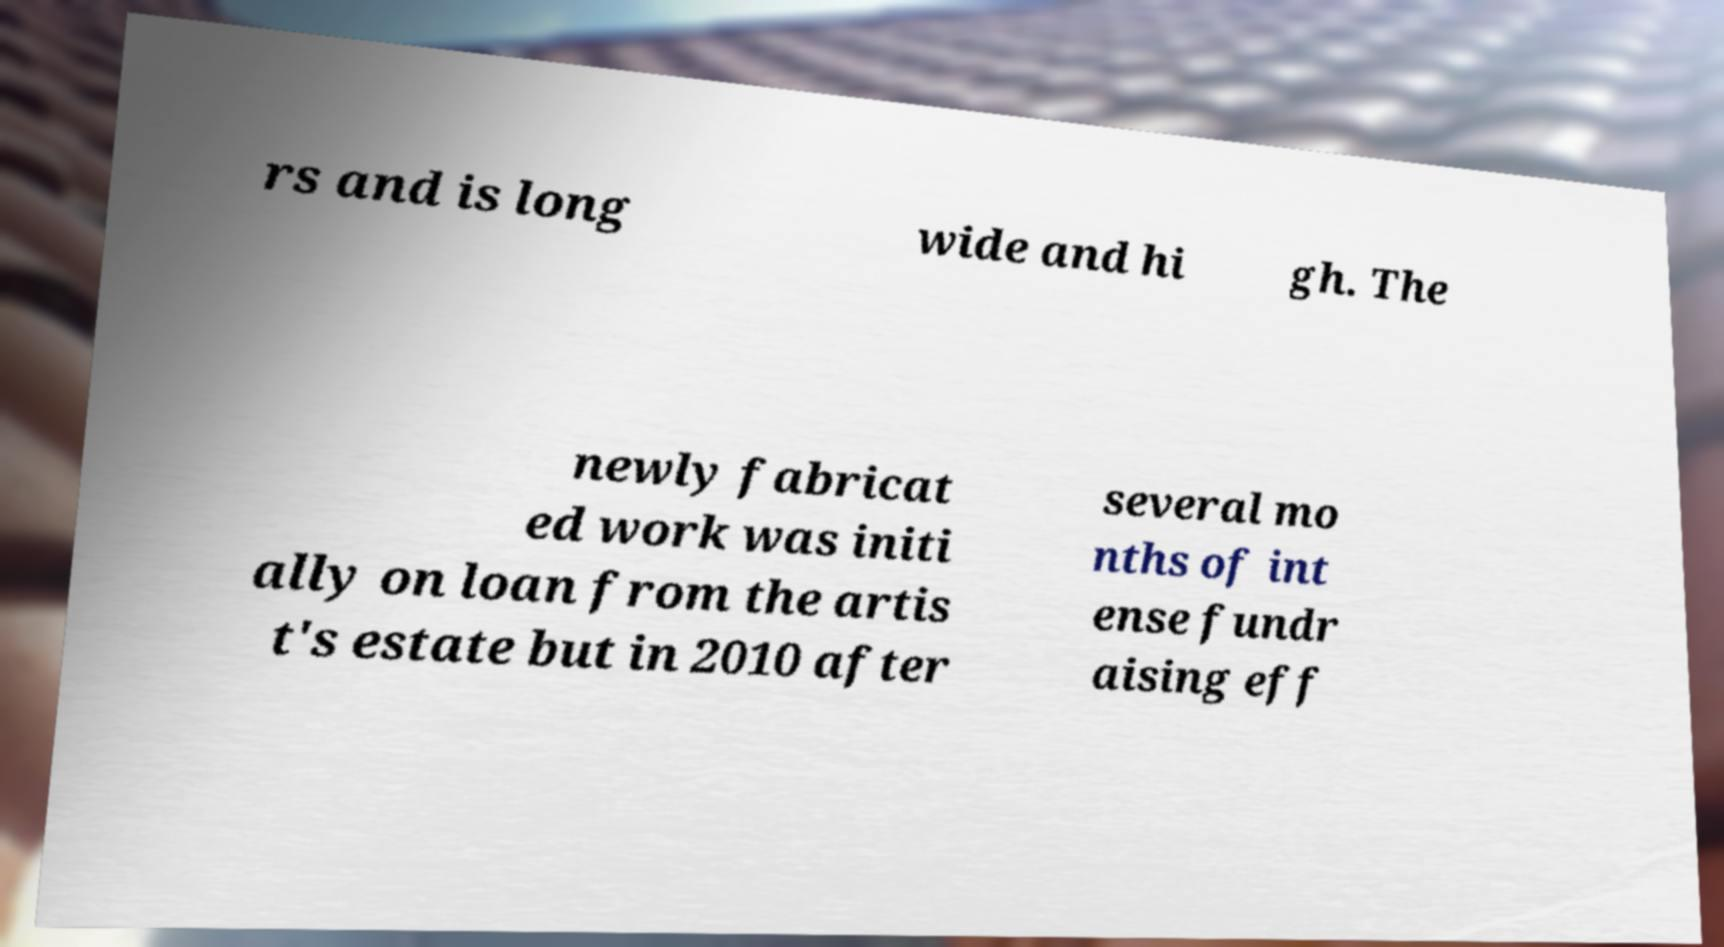Could you assist in decoding the text presented in this image and type it out clearly? rs and is long wide and hi gh. The newly fabricat ed work was initi ally on loan from the artis t's estate but in 2010 after several mo nths of int ense fundr aising eff 